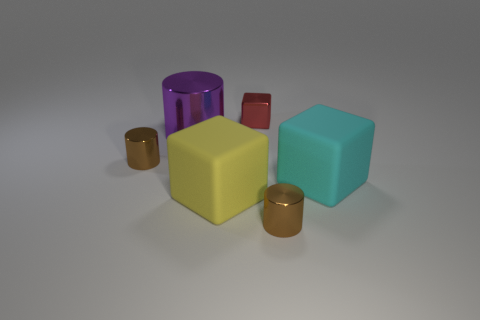Is there another cube that has the same color as the shiny block?
Ensure brevity in your answer.  No. There is a block that is the same material as the large cylinder; what is its size?
Your response must be concise. Small. There is a small brown cylinder in front of the cyan matte cube; what is it made of?
Keep it short and to the point. Metal. There is a tiny brown thing behind the thing to the right of the tiny brown shiny cylinder that is to the right of the large purple object; what shape is it?
Keep it short and to the point. Cylinder. Is the size of the yellow thing the same as the cyan thing?
Your answer should be very brief. Yes. How many objects are either blue rubber cubes or shiny cylinders that are in front of the yellow block?
Offer a terse response. 1. What number of objects are metallic things that are in front of the large cyan matte object or brown objects on the right side of the large yellow matte cube?
Make the answer very short. 1. There is a big yellow object; are there any cylinders left of it?
Your answer should be compact. Yes. There is a large matte block that is right of the small brown metallic cylinder right of the tiny metal object to the left of the large metal cylinder; what color is it?
Ensure brevity in your answer.  Cyan. Is the shape of the big metallic object the same as the tiny red thing?
Your response must be concise. No. 